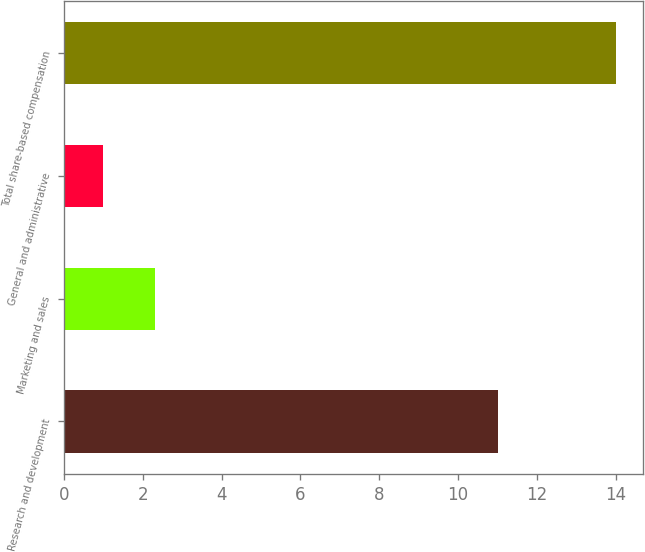Convert chart to OTSL. <chart><loc_0><loc_0><loc_500><loc_500><bar_chart><fcel>Research and development<fcel>Marketing and sales<fcel>General and administrative<fcel>Total share-based compensation<nl><fcel>11<fcel>2.3<fcel>1<fcel>14<nl></chart> 